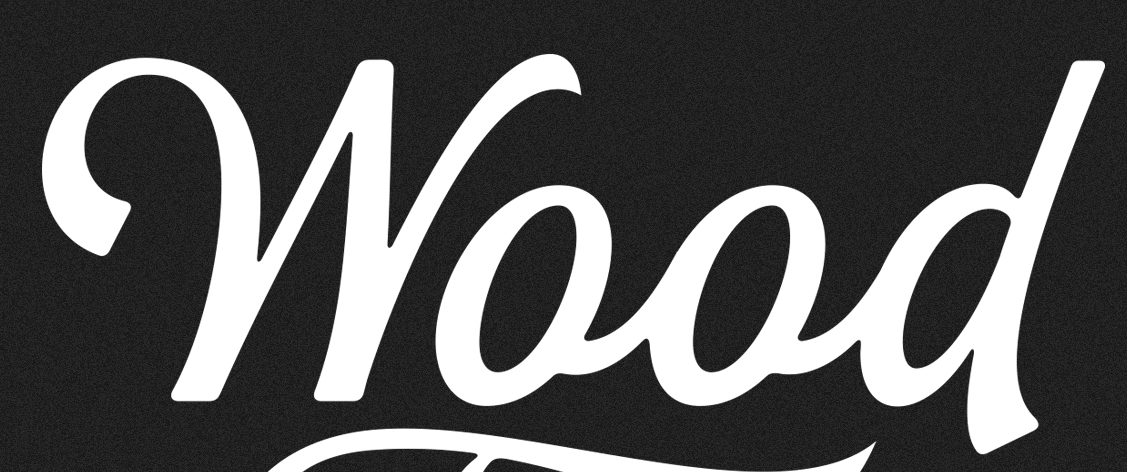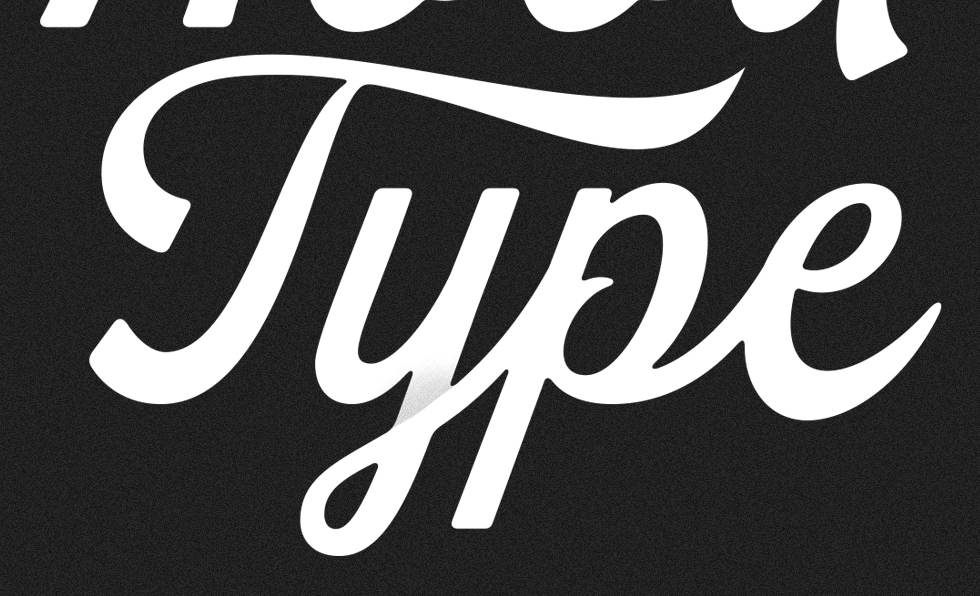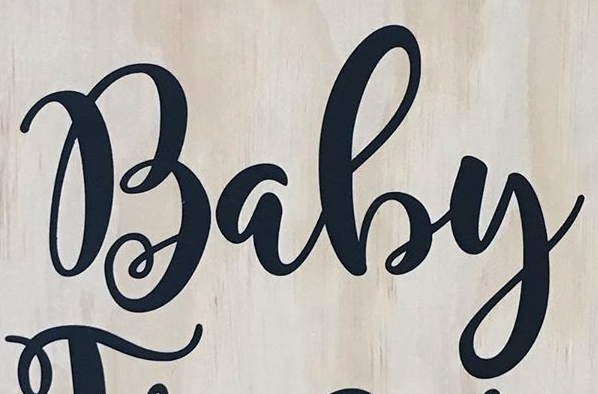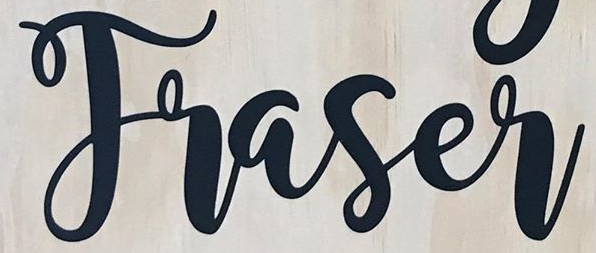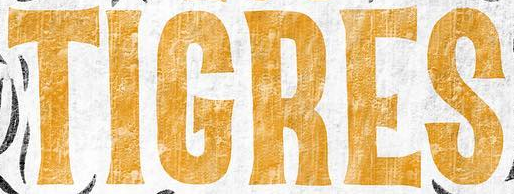Read the text content from these images in order, separated by a semicolon. Wood; Type; Baby; Traser; TIGRES 